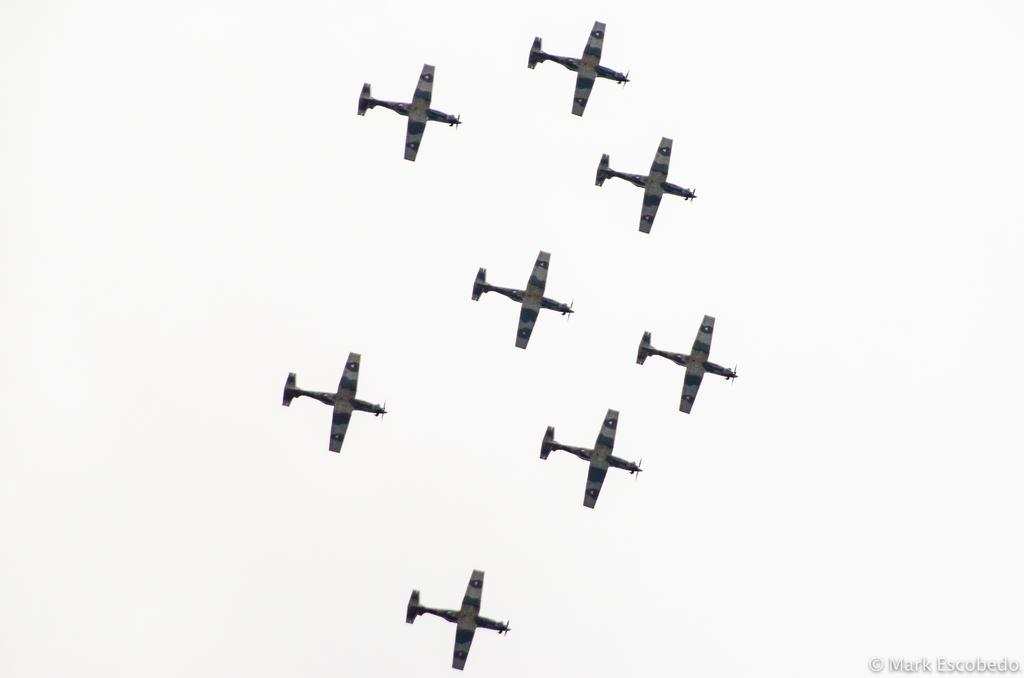What can be seen in the sky in the image? There are aeroplanes in the sky in the image. Is there any text or marking in the image? Yes, there is a watermark at the bottom right corner of the image. What type of stitch is used to create the aeroplanes in the image? The aeroplanes in the image are not created using stitches; they are actual aircraft in the sky. What flavor of tramp can be seen in the image? There is no tramp present in the image, and therefore no flavor can be associated with it. 